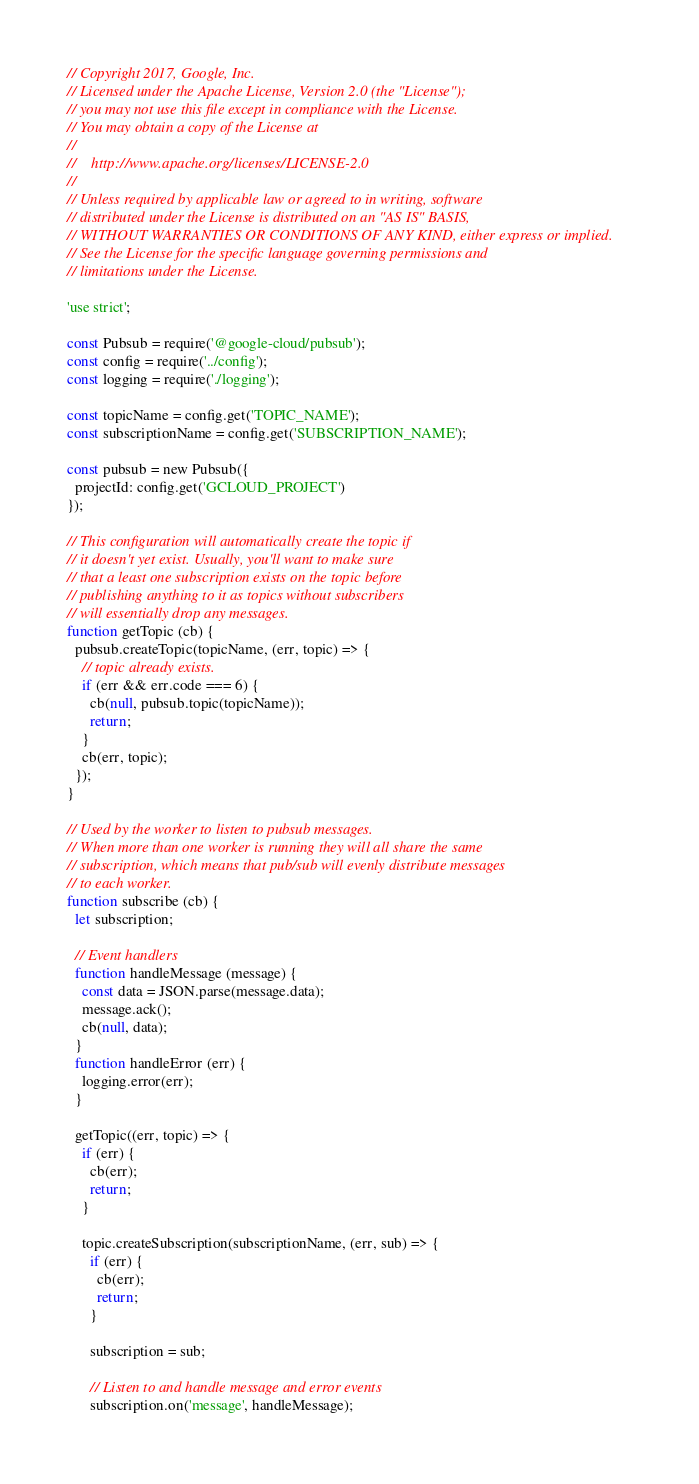Convert code to text. <code><loc_0><loc_0><loc_500><loc_500><_JavaScript_>// Copyright 2017, Google, Inc.
// Licensed under the Apache License, Version 2.0 (the "License");
// you may not use this file except in compliance with the License.
// You may obtain a copy of the License at
//
//    http://www.apache.org/licenses/LICENSE-2.0
//
// Unless required by applicable law or agreed to in writing, software
// distributed under the License is distributed on an "AS IS" BASIS,
// WITHOUT WARRANTIES OR CONDITIONS OF ANY KIND, either express or implied.
// See the License for the specific language governing permissions and
// limitations under the License.

'use strict';

const Pubsub = require('@google-cloud/pubsub');
const config = require('../config');
const logging = require('./logging');

const topicName = config.get('TOPIC_NAME');
const subscriptionName = config.get('SUBSCRIPTION_NAME');

const pubsub = new Pubsub({
  projectId: config.get('GCLOUD_PROJECT')
});

// This configuration will automatically create the topic if
// it doesn't yet exist. Usually, you'll want to make sure
// that a least one subscription exists on the topic before
// publishing anything to it as topics without subscribers
// will essentially drop any messages.
function getTopic (cb) {
  pubsub.createTopic(topicName, (err, topic) => {
    // topic already exists.
    if (err && err.code === 6) {
      cb(null, pubsub.topic(topicName));
      return;
    }
    cb(err, topic);
  });
}

// Used by the worker to listen to pubsub messages.
// When more than one worker is running they will all share the same
// subscription, which means that pub/sub will evenly distribute messages
// to each worker.
function subscribe (cb) {
  let subscription;

  // Event handlers
  function handleMessage (message) {
    const data = JSON.parse(message.data);
    message.ack();
    cb(null, data);
  }
  function handleError (err) {
    logging.error(err);
  }

  getTopic((err, topic) => {
    if (err) {
      cb(err);
      return;
    }

    topic.createSubscription(subscriptionName, (err, sub) => {
      if (err) {
        cb(err);
        return;
      }

      subscription = sub;

      // Listen to and handle message and error events
      subscription.on('message', handleMessage);</code> 